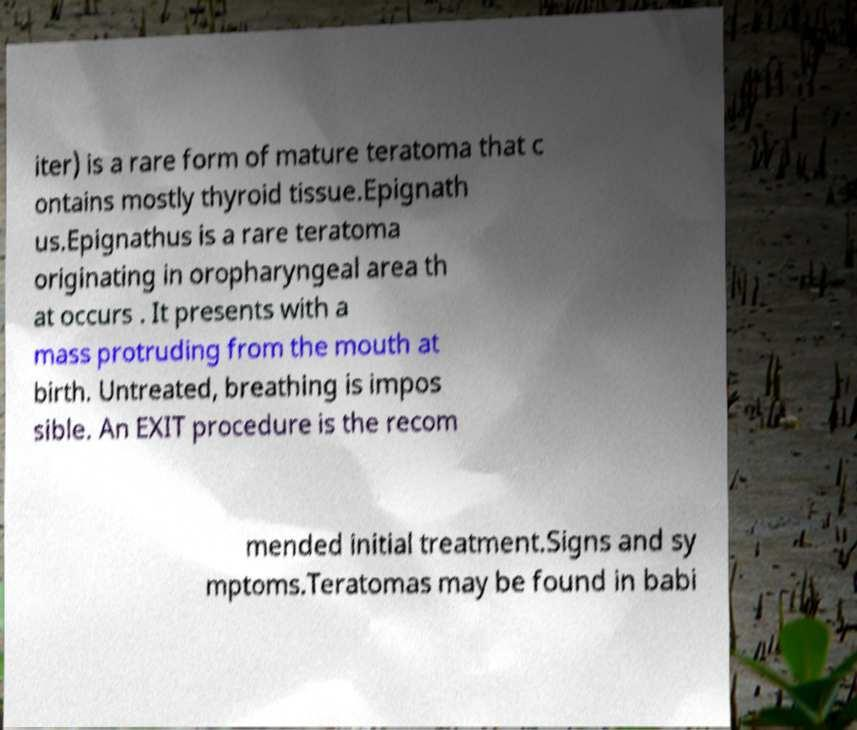Can you read and provide the text displayed in the image?This photo seems to have some interesting text. Can you extract and type it out for me? iter) is a rare form of mature teratoma that c ontains mostly thyroid tissue.Epignath us.Epignathus is a rare teratoma originating in oropharyngeal area th at occurs . It presents with a mass protruding from the mouth at birth. Untreated, breathing is impos sible. An EXIT procedure is the recom mended initial treatment.Signs and sy mptoms.Teratomas may be found in babi 